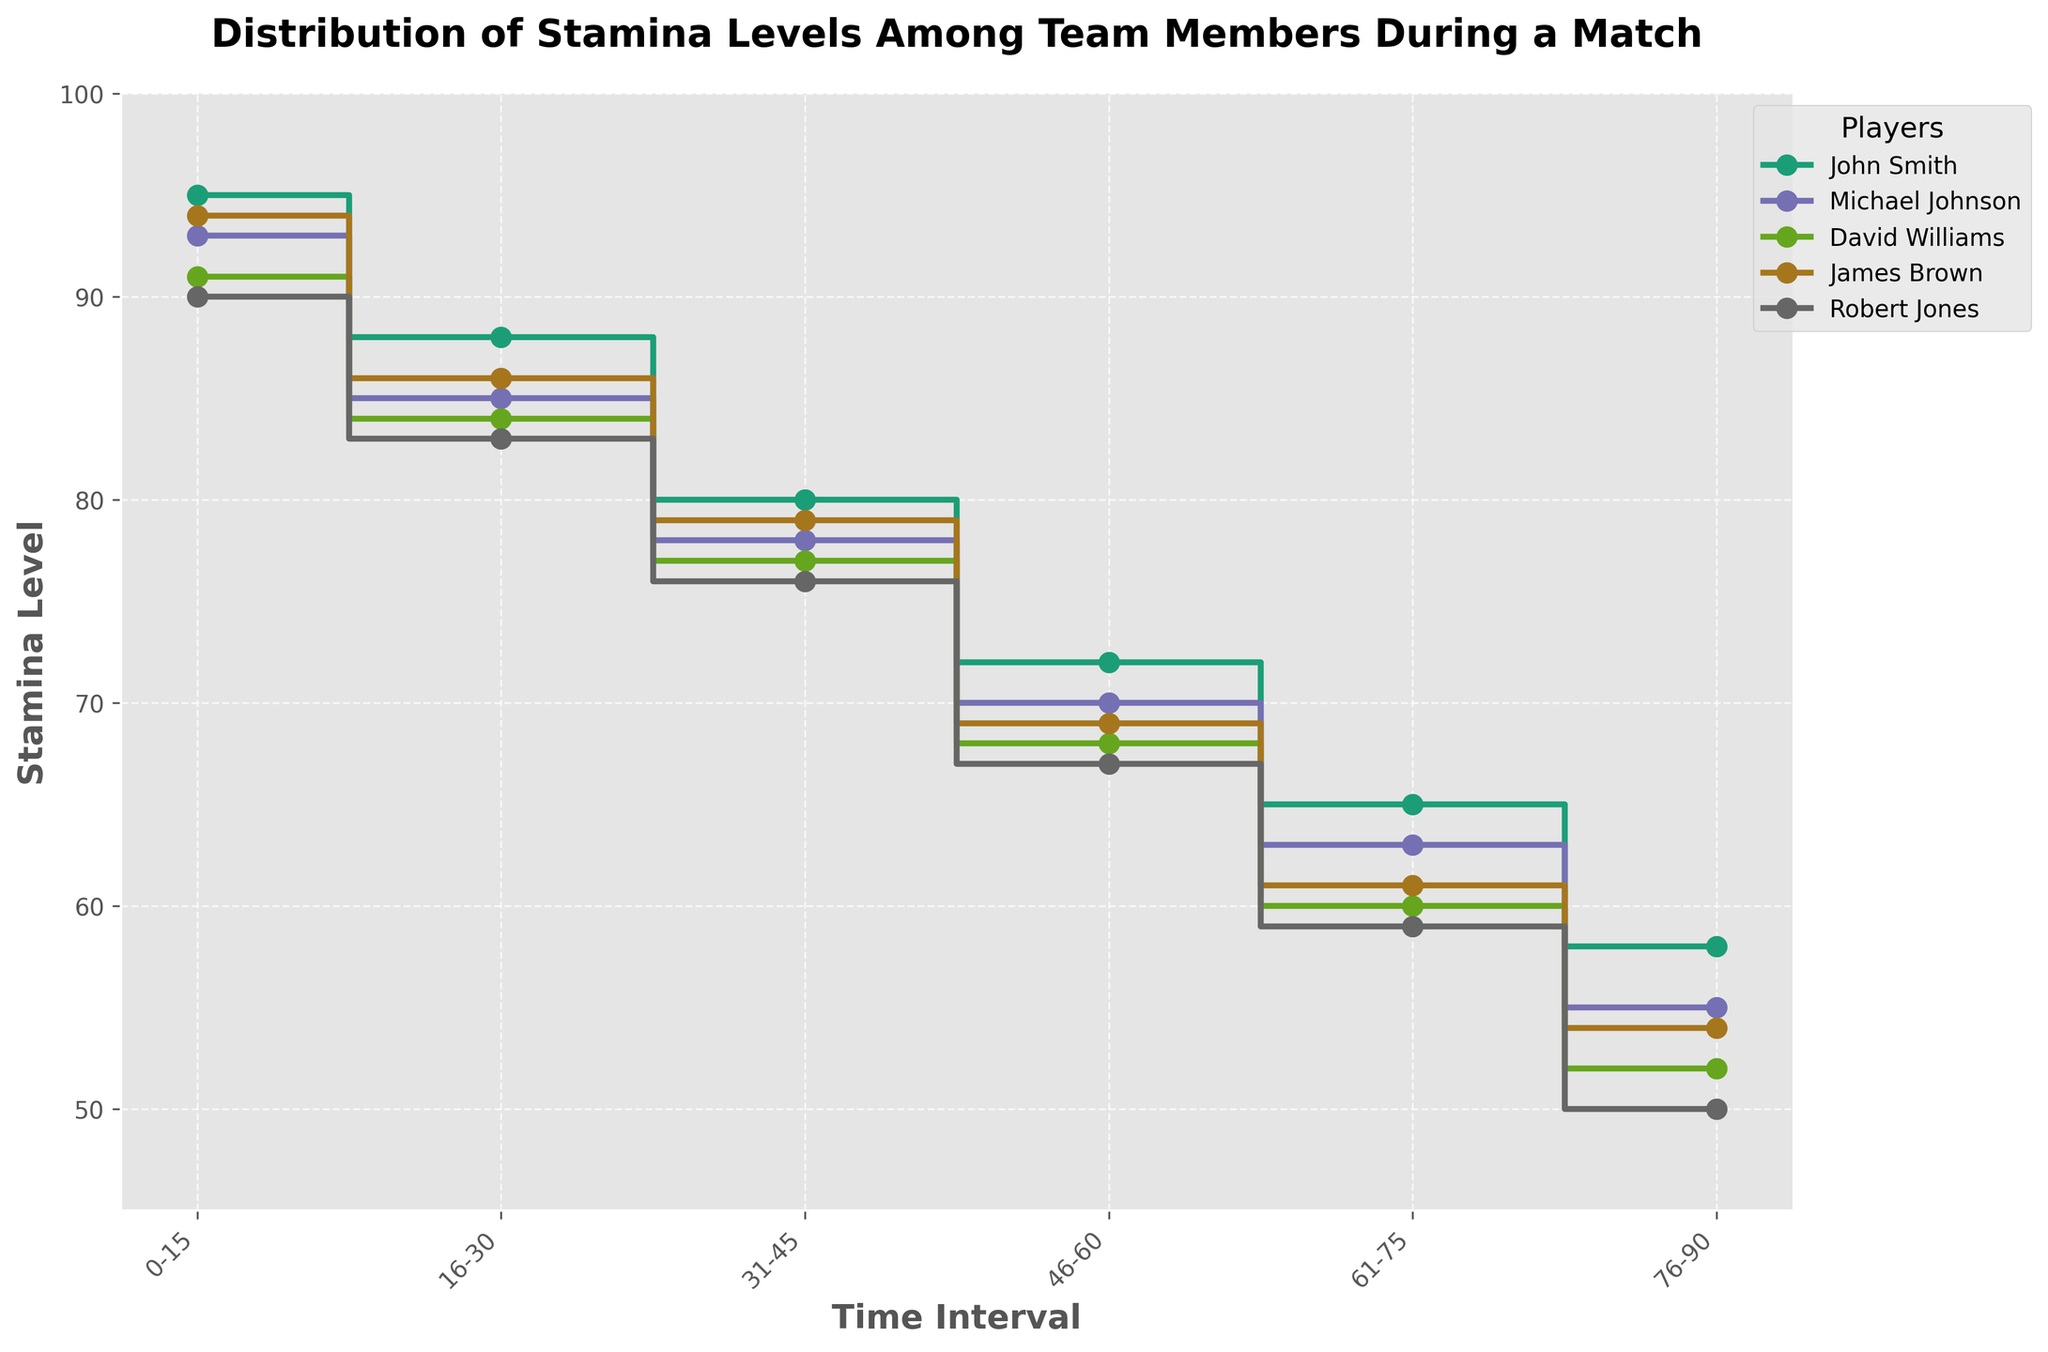What is the title of the plot? The title of the plot is written at the top of the figure in bold font. It reads, "Distribution of Stamina Levels Among Team Members During a Match."
Answer: Distribution of Stamina Levels Among Team Members During a Match How many players' stamina levels are tracked in the plot? The legend at the upper right corner of the plot lists the names of the players being tracked. There are five names: John Smith, Michael Johnson, David Williams, James Brown, and Robert Jones.
Answer: 5 Which player has the highest stamina level at the beginning of the match? To find this, observe the first set of data points at the “0-15” time interval. John Smith has the highest stamina level of 95.
Answer: John Smith What is the stamina level of Robert Jones at the end of the match? At the last time interval "76-90", look for Robert Jones' data point. His stamina level is 50.
Answer: 50 Which player's stamina level decreases the least from the beginning to the end of the match? Calculate the stamina drop for each player from the “0-15” to “76-90” interval and compare them. John Smith's decrease is from 95 to 58, which is a drop of 37, the smallest among all players (John Smith: 95-58=37, Michael Johnson: 93-55=38, David Williams: 91-52=39, James Brown: 94-54=40, Robert Jones: 90-50=40).
Answer: John Smith What is the average stamina level of James Brown over the entire match? Find James Brown's stamina levels at each interval (94, 86, 79, 69, 61, 54) and calculate the average: (94+86+79+69+61+54)/6 = 73.83.
Answer: 73.83 Between which two time intervals does Michael Johnson experience the largest drop in stamina? Calculate the drops between each consecutive interval for Michael Johnson (93-85=8, 85-78=7, 78-70=8, 70-63=7, 63-55=8). The largest drops are between "0-15" to "16-30", "31-45" to "46-60", and "61-75" to "76-90", each with a drop of 8.
Answer: 0-15 to 16-30, 31-45 to 46-60, 61-75 to 76-90 What is the combined stamina level of all players at the 31-45 minute interval? Add the stamina levels of all players at "31-45" (John Smith: 80, Michael Johnson: 78, David Williams: 77, James Brown: 79, Robert Jones: 76). The combined stamina level is 80 + 78 + 77 + 79 + 76 = 390.
Answer: 390 How does the stamina level trend of David Williams compare to that of Robert Jones over the match? Both players' stamina levels decrease over time, but it is visible in the plot that David Williams and Robert Jones experience a similar steady decline, maintaining almost parallel lines throughout the match.
Answer: Similar steady decline During which time interval does the team (all players combined) have the lowest average stamina level? Calculate the average stamina level for each interval and compare them. The time interval "76-90" has: (58+55+52+54+50)/5 = 53.8, which is the lowest average compared to other intervals.
Answer: 76-90 